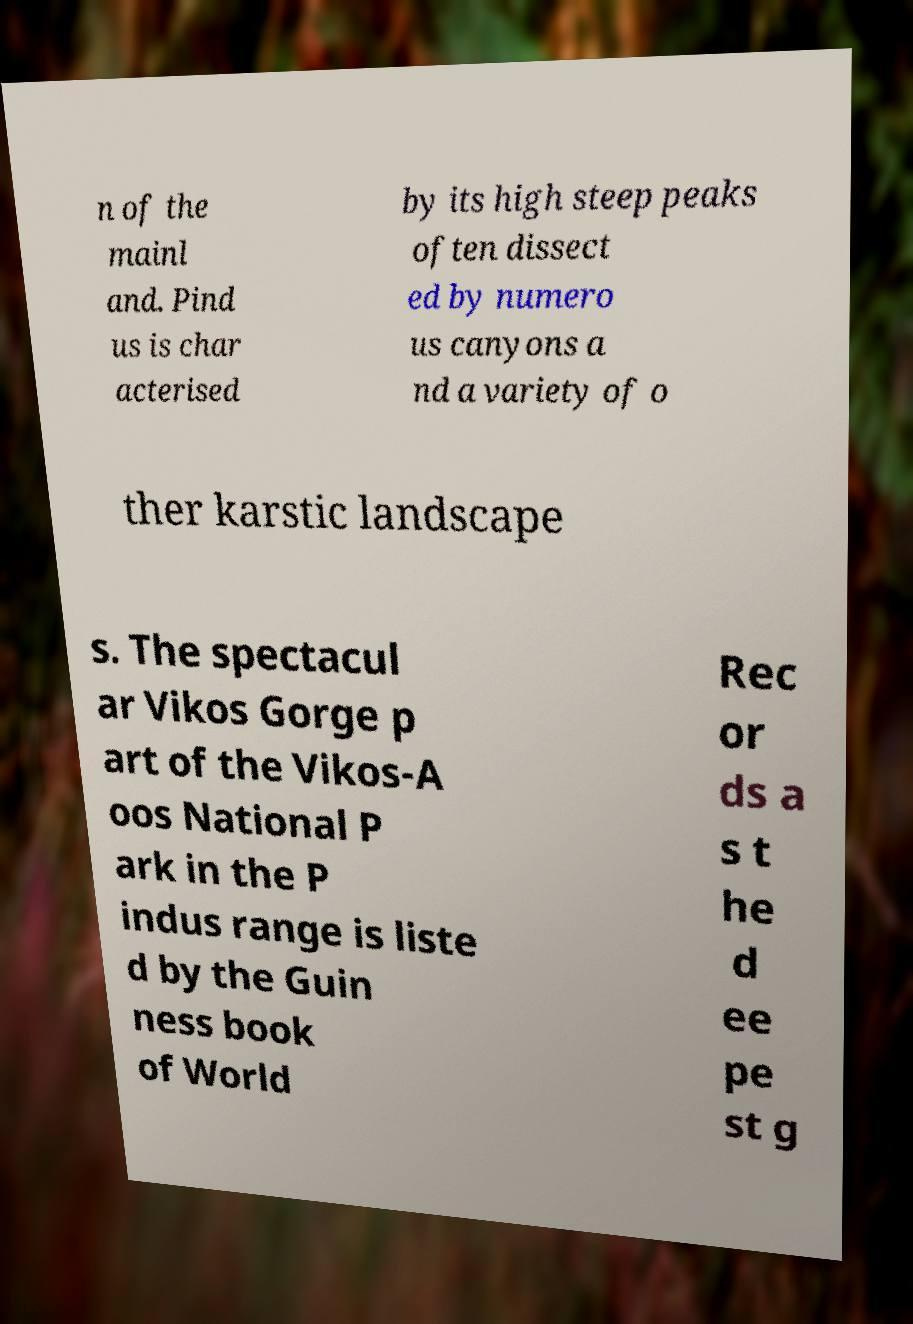Please identify and transcribe the text found in this image. n of the mainl and. Pind us is char acterised by its high steep peaks often dissect ed by numero us canyons a nd a variety of o ther karstic landscape s. The spectacul ar Vikos Gorge p art of the Vikos-A oos National P ark in the P indus range is liste d by the Guin ness book of World Rec or ds a s t he d ee pe st g 